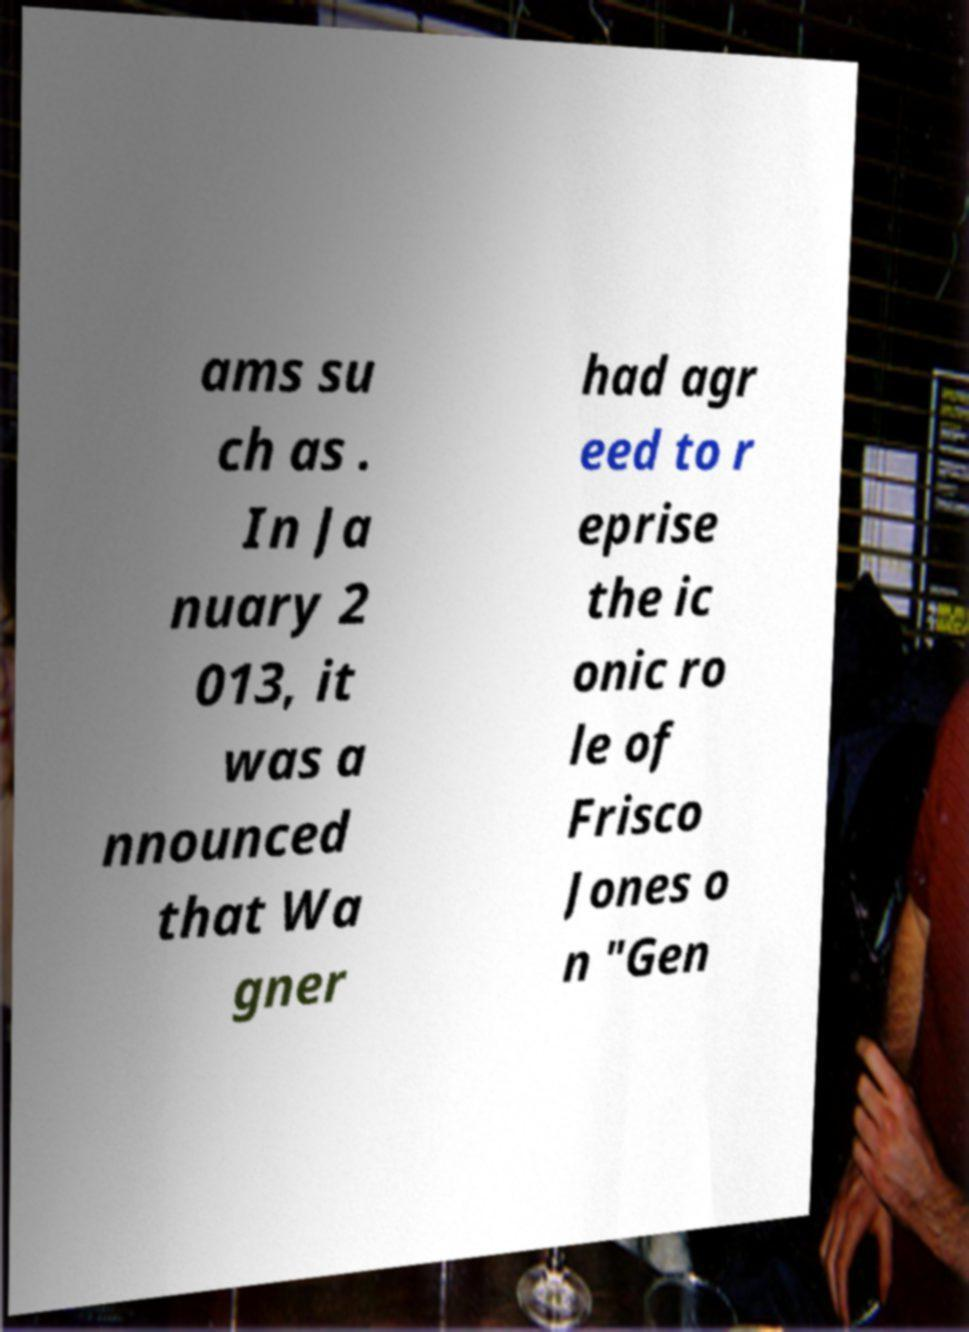Can you read and provide the text displayed in the image?This photo seems to have some interesting text. Can you extract and type it out for me? ams su ch as . In Ja nuary 2 013, it was a nnounced that Wa gner had agr eed to r eprise the ic onic ro le of Frisco Jones o n "Gen 